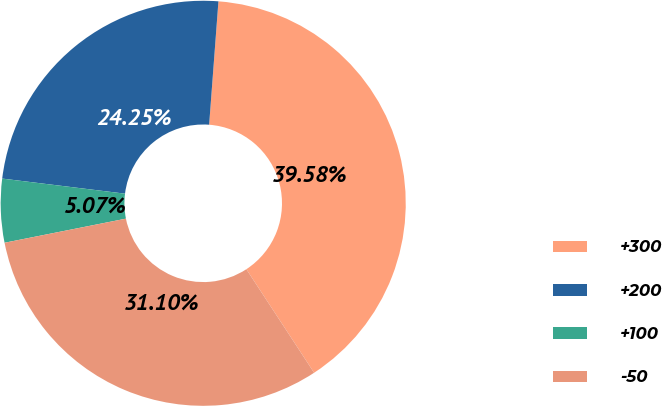Convert chart to OTSL. <chart><loc_0><loc_0><loc_500><loc_500><pie_chart><fcel>+300<fcel>+200<fcel>+100<fcel>-50<nl><fcel>39.58%<fcel>24.25%<fcel>5.07%<fcel>31.1%<nl></chart> 